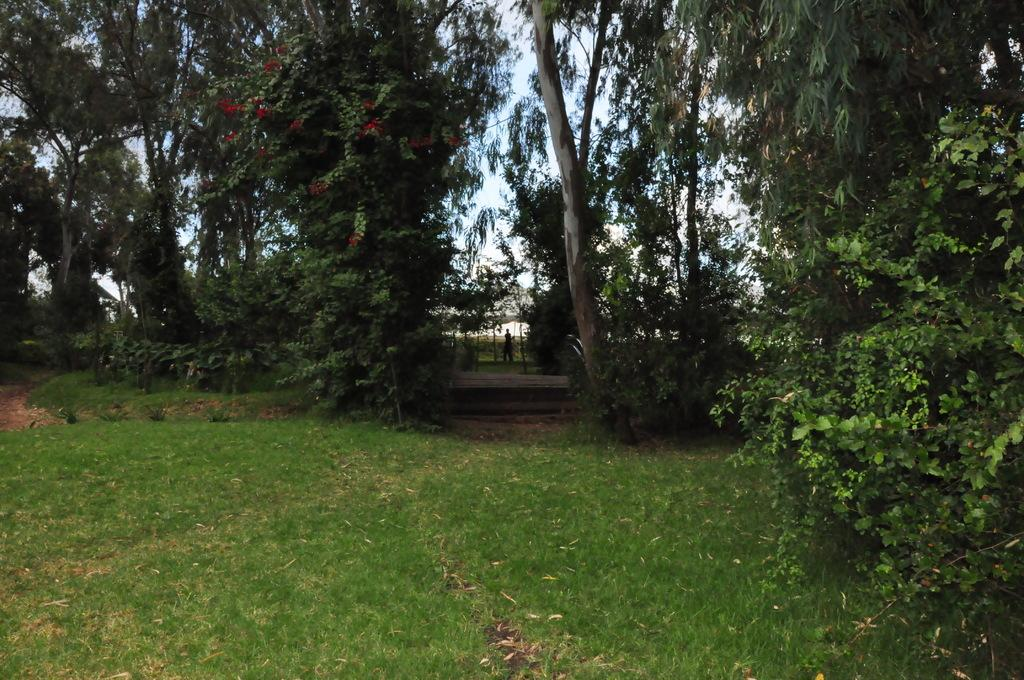What type of terrain is visible in the image? There is grassy land in the image. What type of vegetation can be seen in the image? There are plants and trees in the image. What is visible in the background of the image? The sky is visible behind the trees. Can you describe the person in the image? There is a person in the middle of the image. What type of magic is being performed by the person in the image? There is no indication of magic or any magical activity in the image. 